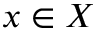Convert formula to latex. <formula><loc_0><loc_0><loc_500><loc_500>x \in X</formula> 